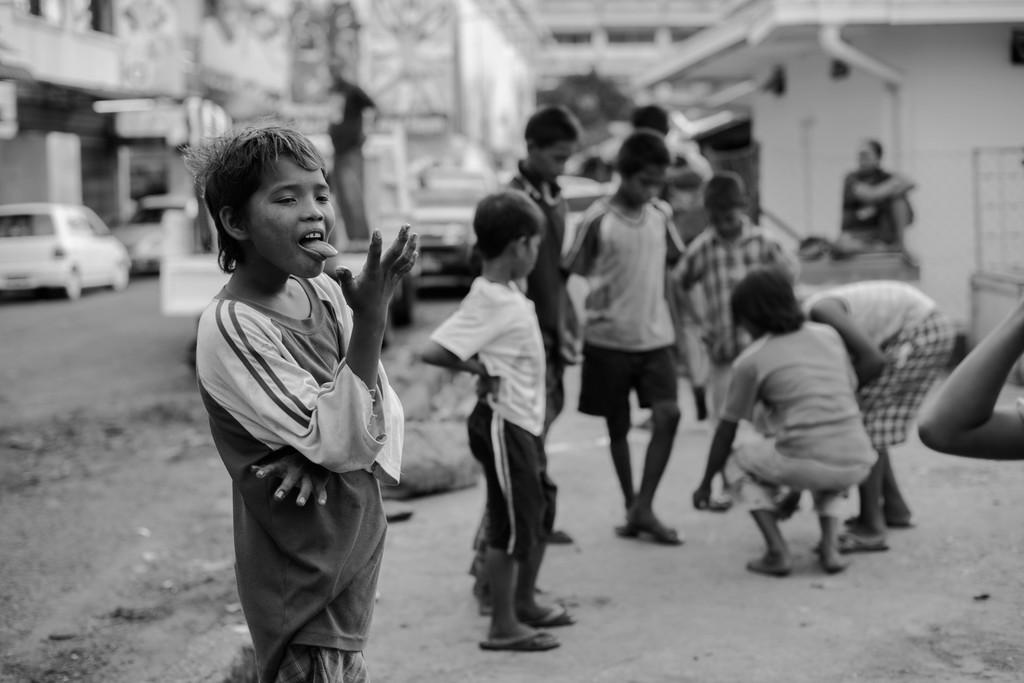What is the color scheme of the image? The image is black and white. What can be seen in the foreground of the image? There is a group of children in the image. How is the background of the children depicted? The background of the children is blurred. What type of library can be seen in the background of the image? There is no library present in the image; it is a black and white image of a group of children with a blurred background. What unit of measurement is used to determine the distance between the children in the image? The provided facts do not mention any specific unit of measurement for determining the distance between the children in the image. 